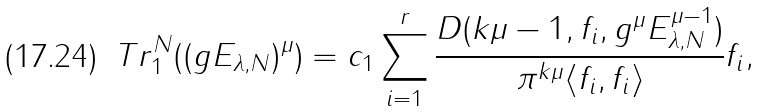<formula> <loc_0><loc_0><loc_500><loc_500>T r ^ { N } _ { 1 } ( ( g E _ { \lambda , N } ) ^ { \mu } ) = c _ { 1 } \sum _ { i = 1 } ^ { r } \frac { D ( k \mu - 1 , f _ { i } , g ^ { \mu } E _ { \lambda , N } ^ { \mu - 1 } ) } { \pi ^ { k \mu } \langle f _ { i } , f _ { i } \rangle } f _ { i } ,</formula> 